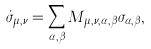Convert formula to latex. <formula><loc_0><loc_0><loc_500><loc_500>\dot { \sigma } _ { \mu , \nu } = \sum _ { \alpha , \beta } M _ { \mu , \nu , \alpha , \beta } \sigma _ { \alpha , \beta } ,</formula> 